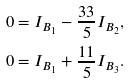<formula> <loc_0><loc_0><loc_500><loc_500>0 & = I _ { B _ { 1 } } - \frac { 3 3 } { 5 } I _ { B _ { 2 } } , \\ 0 & = I _ { B _ { 1 } } + \frac { 1 1 } { 5 } I _ { B _ { 3 } } .</formula> 